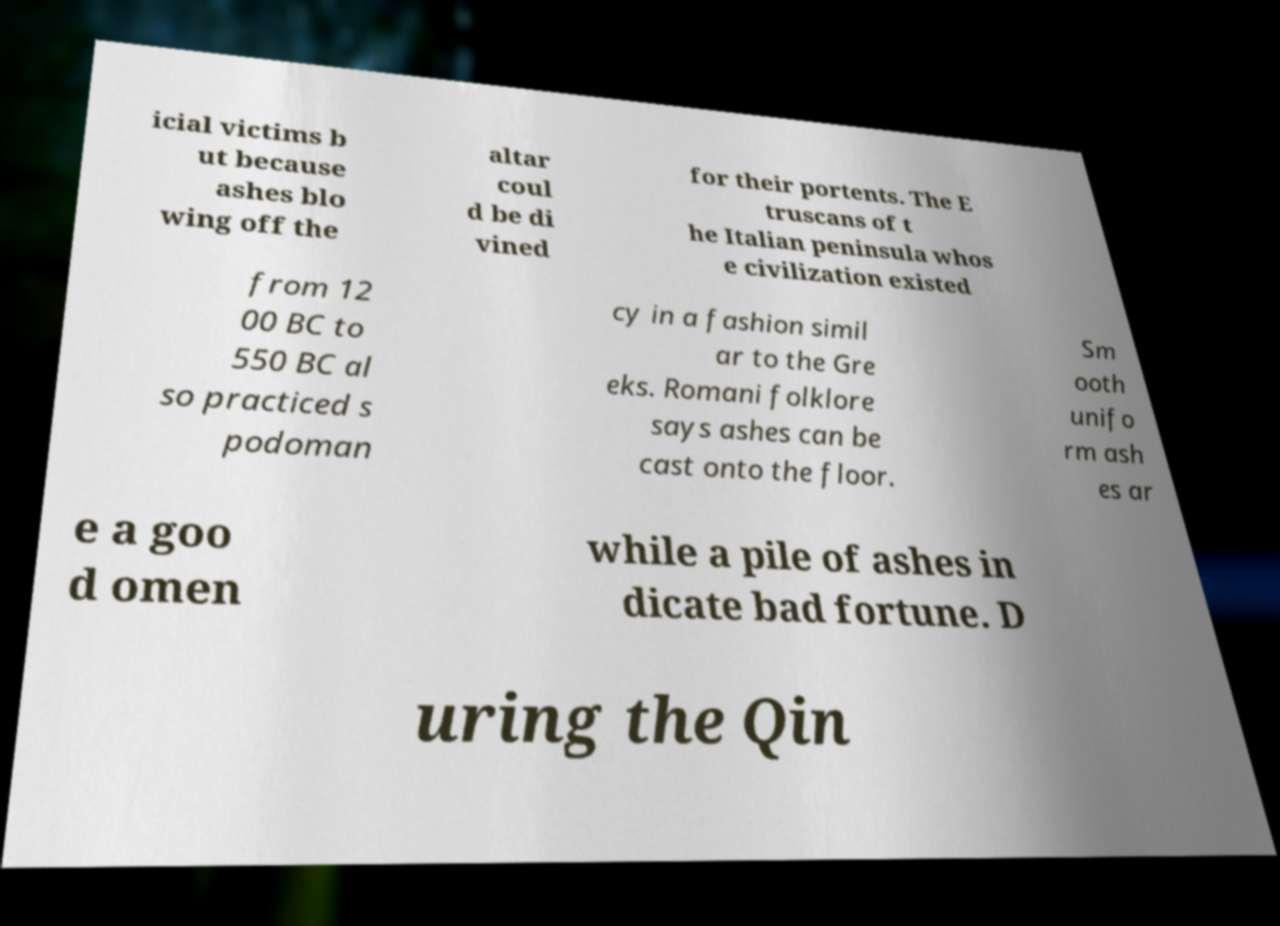Please identify and transcribe the text found in this image. icial victims b ut because ashes blo wing off the altar coul d be di vined for their portents. The E truscans of t he Italian peninsula whos e civilization existed from 12 00 BC to 550 BC al so practiced s podoman cy in a fashion simil ar to the Gre eks. Romani folklore says ashes can be cast onto the floor. Sm ooth unifo rm ash es ar e a goo d omen while a pile of ashes in dicate bad fortune. D uring the Qin 